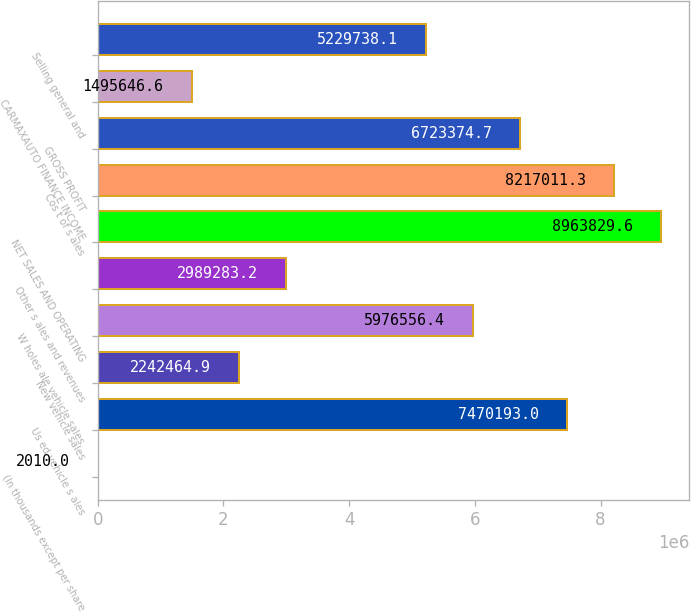<chart> <loc_0><loc_0><loc_500><loc_500><bar_chart><fcel>(In thousands except per share<fcel>Us ed vehicle s ales<fcel>New vehicle sales<fcel>W holes ale vehicle sales<fcel>Other s ales and revenues<fcel>NET SALES AND OPERATING<fcel>Cos t of s ales<fcel>GROSS PROFIT<fcel>CARMAXAUTO FINANCE INCOME<fcel>Selling general and<nl><fcel>2010<fcel>7.47019e+06<fcel>2.24246e+06<fcel>5.97656e+06<fcel>2.98928e+06<fcel>8.96383e+06<fcel>8.21701e+06<fcel>6.72337e+06<fcel>1.49565e+06<fcel>5.22974e+06<nl></chart> 